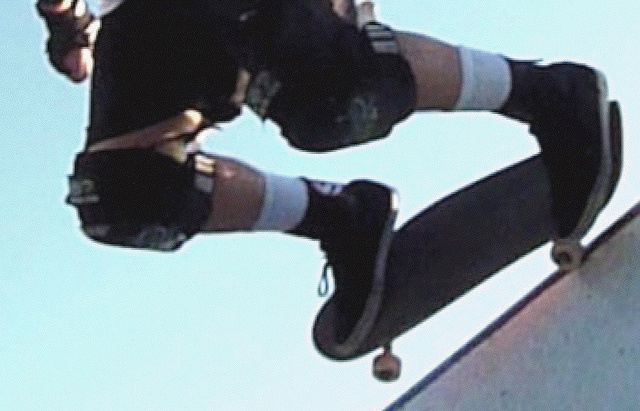Describe the objects in this image and their specific colors. I can see people in lightblue, black, gray, and darkgray tones and skateboard in lightblue, black, gray, and lightgray tones in this image. 